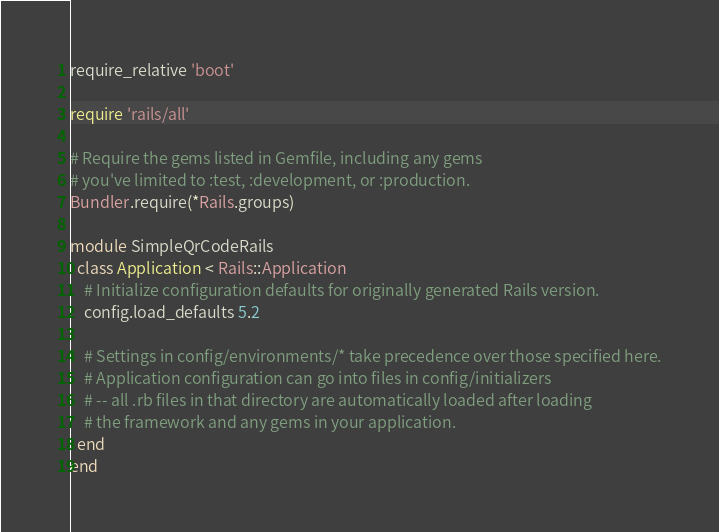<code> <loc_0><loc_0><loc_500><loc_500><_Ruby_>require_relative 'boot'

require 'rails/all'

# Require the gems listed in Gemfile, including any gems
# you've limited to :test, :development, or :production.
Bundler.require(*Rails.groups)

module SimpleQrCodeRails
  class Application < Rails::Application
    # Initialize configuration defaults for originally generated Rails version.
    config.load_defaults 5.2

    # Settings in config/environments/* take precedence over those specified here.
    # Application configuration can go into files in config/initializers
    # -- all .rb files in that directory are automatically loaded after loading
    # the framework and any gems in your application.
  end
end
</code> 